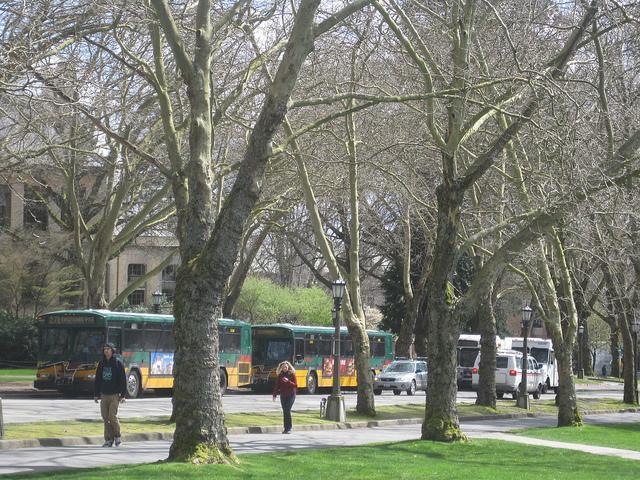How many buses are visible?
Give a very brief answer. 2. How many dogs are laying on the floor?
Give a very brief answer. 0. 